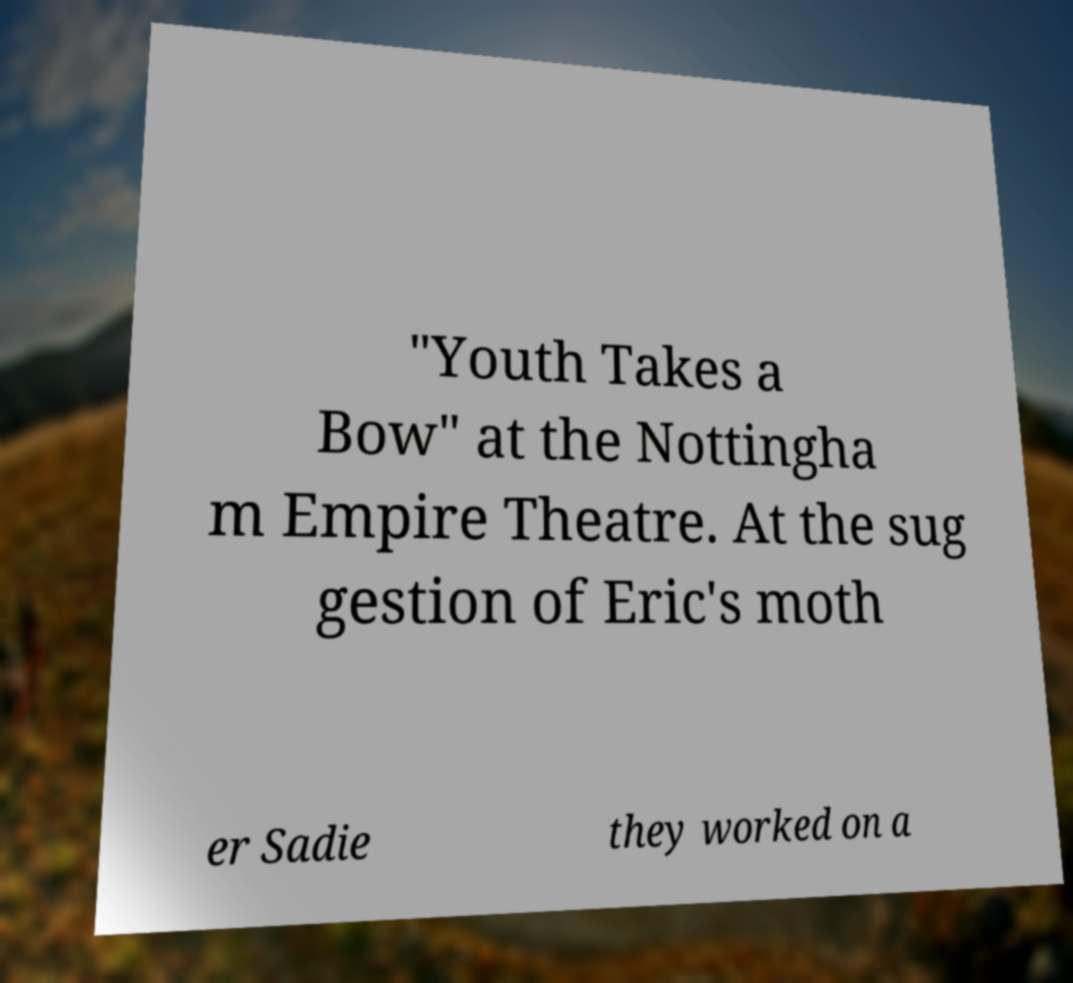Please identify and transcribe the text found in this image. "Youth Takes a Bow" at the Nottingha m Empire Theatre. At the sug gestion of Eric's moth er Sadie they worked on a 